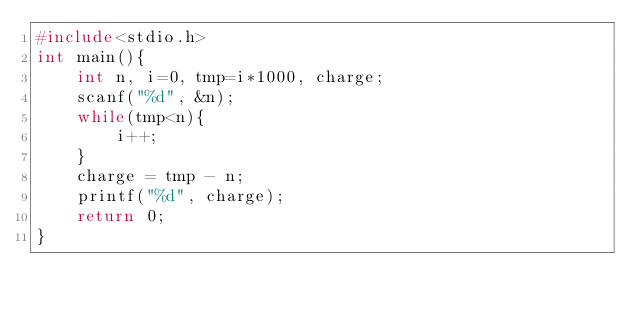Convert code to text. <code><loc_0><loc_0><loc_500><loc_500><_C_>#include<stdio.h>
int main(){
    int n, i=0, tmp=i*1000, charge;
    scanf("%d", &n);
    while(tmp<n){
        i++;
    }
    charge = tmp - n;
    printf("%d", charge);
    return 0;
}
</code> 